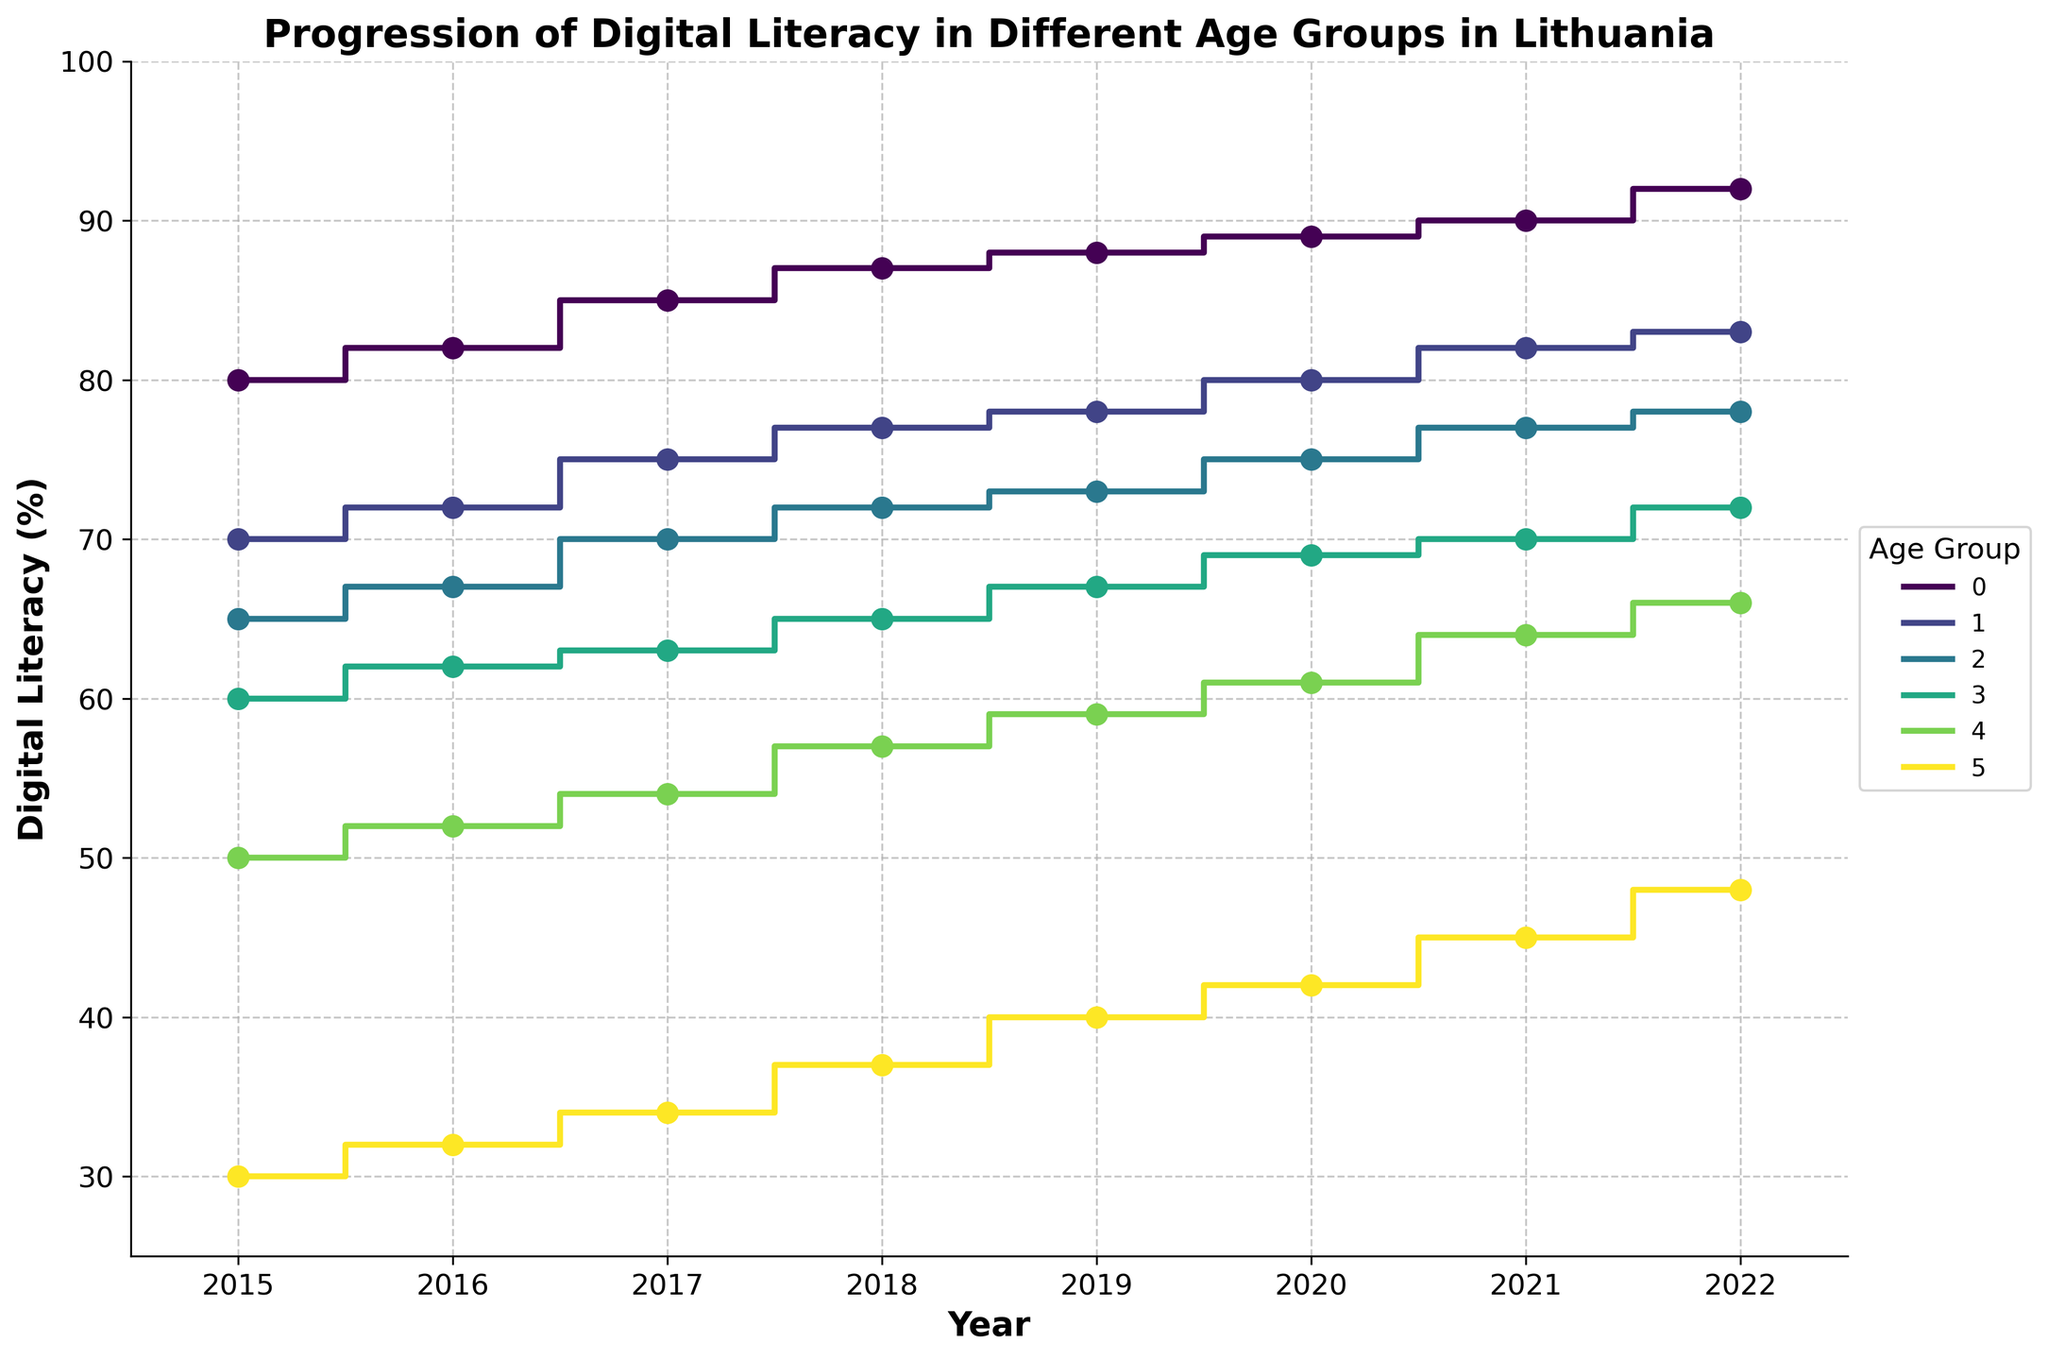what is the title of the figure? The title of the figure is displayed at the top. It reads "Progression of Digital Literacy in Different Age Groups in Lithuania."
Answer: Progression of Digital Literacy in Different Age Groups in Lithuania Which age group has the highest digital literacy percentage in 2022? By observing the highest data point in the year 2022, the 15-24 age group has the highest digital literacy percentage.
Answer: 15-24 What is the average digital literacy percentage for the 25-34 age group from 2015 to 2022? To find the average, add the percentages from 2015 to 2022 for the 25-34 age group (70 + 72 + 75 + 77 + 78 + 80 + 82 + 83) and divide by the number of years (8). So, the sum is 617 and the average is 617/8.
Answer: 77.125 Which age group shows the largest increase in digital literacy from 2015 to 2022? To determine the largest increase, subtract the 2015 percentage from the 2022 percentage for each age group and compare the differences: 15-24 (12), 25-34 (13), 35-44 (13), 45-54 (12), 55-64 (16), 65+ (18). The age group 65+ has the largest increase.
Answer: 65+ How does the digital literacy trend of the 45-54 age group compare to the 35-44 age group from 2015 to 2022? By comparing the trends, both age groups show an upward progression in digital literacy, but the 35-44 age group has slightly higher percentages each year. The exact values are slightly higher for 35-44 across all years.
Answer: 35-44 is higher Which year saw the digital literacy percentage of the 65+ age group exceed 40% for the first time? Observing the 65+ age group percentages, the year when it first exceeds 40% is 2019.
Answer: 2019 What was the rate of change in digital literacy for the 55-64 age group from 2015 to 2022? To find the rate of change, subtract the 2015 value from the 2022 value and then divide by the number of years. Thus, for the 55-64 age group: (66 - 50) / 7 ≈ 2.29% per year.
Answer: ≈2.29% Which two age groups had identical digital literacy percentages in 2015? By comparing the 2015 values across age groups, the 45-54 and 55-64 age groups both have different values (60 and 50 respectively) meaning no two groups have the same literacy percentage.
Answer: None What is the digital literacy gap between the youngest and oldest age groups in 2022? To find the gap, subtract the 2022 percentage of the 65+ age group from the 2022 percentage of the 15-24 age group: 92 - 48 = 44.
Answer: 44 